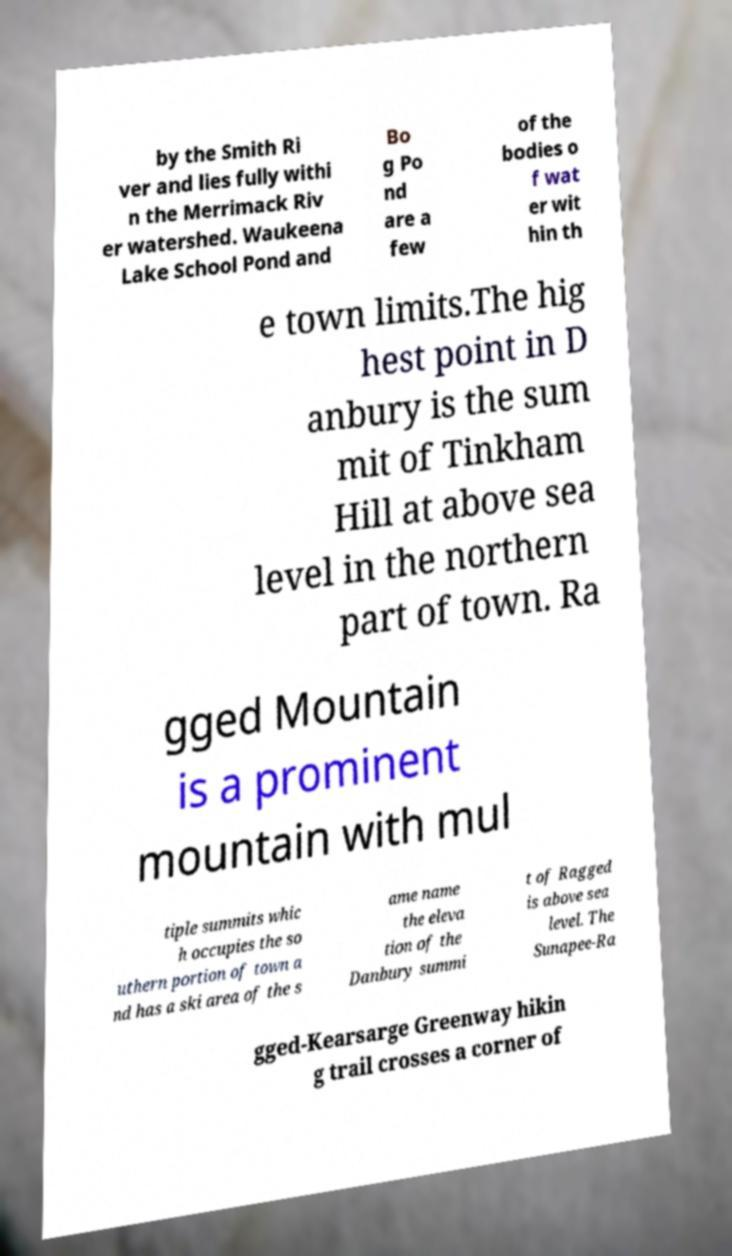Please read and relay the text visible in this image. What does it say? by the Smith Ri ver and lies fully withi n the Merrimack Riv er watershed. Waukeena Lake School Pond and Bo g Po nd are a few of the bodies o f wat er wit hin th e town limits.The hig hest point in D anbury is the sum mit of Tinkham Hill at above sea level in the northern part of town. Ra gged Mountain is a prominent mountain with mul tiple summits whic h occupies the so uthern portion of town a nd has a ski area of the s ame name the eleva tion of the Danbury summi t of Ragged is above sea level. The Sunapee-Ra gged-Kearsarge Greenway hikin g trail crosses a corner of 